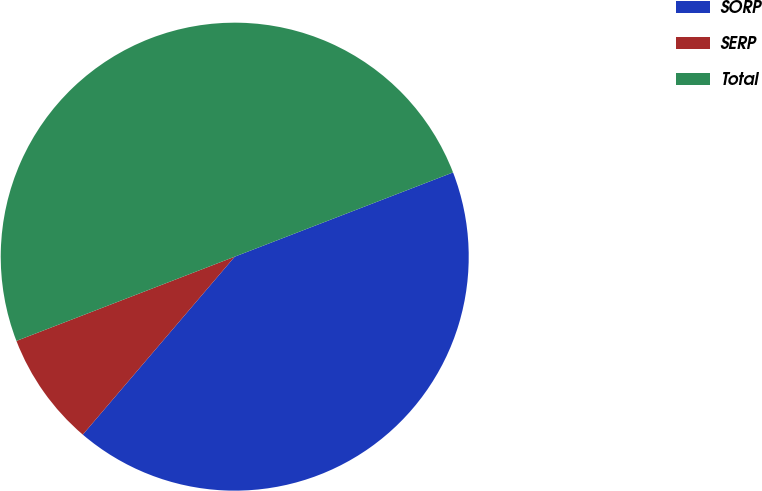<chart> <loc_0><loc_0><loc_500><loc_500><pie_chart><fcel>SORP<fcel>SERP<fcel>Total<nl><fcel>42.11%<fcel>7.89%<fcel>50.0%<nl></chart> 